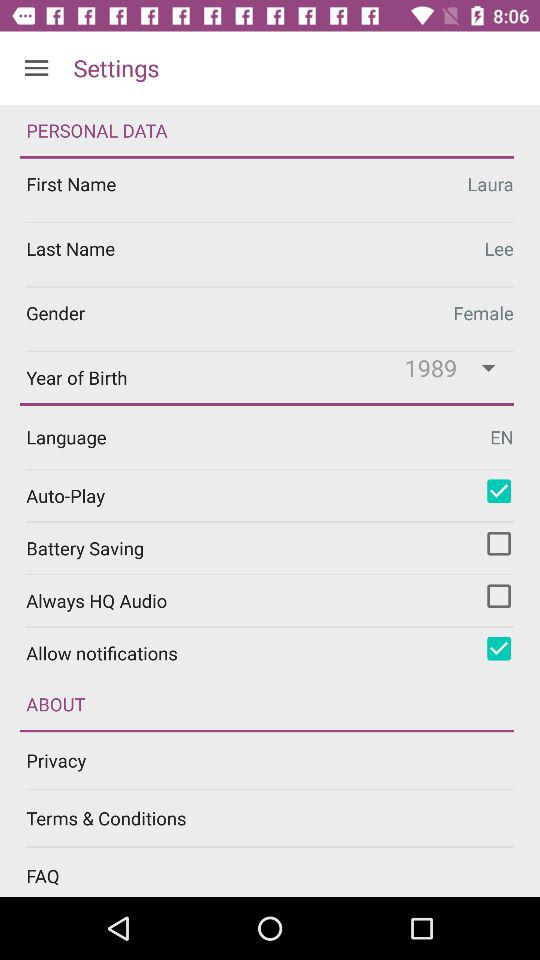What is the selected language? The selected language is English. 